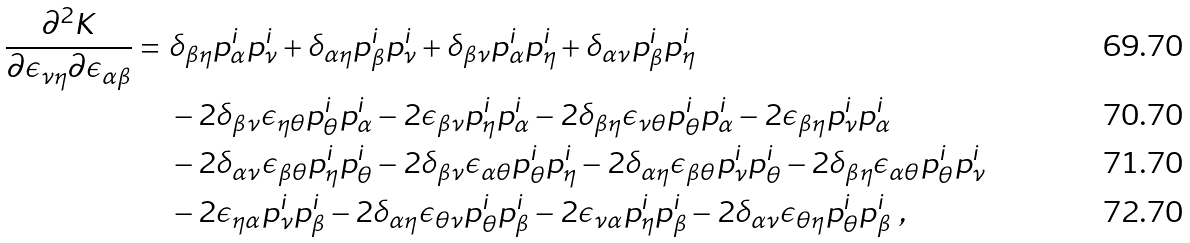<formula> <loc_0><loc_0><loc_500><loc_500>\frac { \partial ^ { 2 } K } { \partial \epsilon _ { \nu \eta } \partial \epsilon _ { \alpha \beta } } = \ & \delta _ { \beta \eta } p ^ { i } _ { \alpha } p ^ { i } _ { \nu } + \delta _ { \alpha \eta } p ^ { i } _ { \beta } p ^ { i } _ { \nu } + \delta _ { \beta \nu } p ^ { i } _ { \alpha } p ^ { i } _ { \eta } + \delta _ { \alpha \nu } p ^ { i } _ { \beta } p ^ { i } _ { \eta } \\ & - 2 \delta _ { \beta \nu } \epsilon _ { \eta \theta } p ^ { i } _ { \theta } p ^ { i } _ { \alpha } - 2 \epsilon _ { \beta \nu } p ^ { i } _ { \eta } p ^ { i } _ { \alpha } - 2 \delta _ { \beta \eta } \epsilon _ { \nu \theta } p ^ { i } _ { \theta } p ^ { i } _ { \alpha } - 2 \epsilon _ { \beta \eta } p ^ { i } _ { \nu } p ^ { i } _ { \alpha } \\ & - 2 \delta _ { \alpha \nu } \epsilon _ { \beta \theta } p ^ { i } _ { \eta } p ^ { i } _ { \theta } - 2 \delta _ { \beta \nu } \epsilon _ { \alpha \theta } p ^ { i } _ { \theta } p ^ { i } _ { \eta } - 2 \delta _ { \alpha \eta } \epsilon _ { \beta \theta } p ^ { i } _ { \nu } p ^ { i } _ { \theta } - 2 \delta _ { \beta \eta } \epsilon _ { \alpha \theta } p ^ { i } _ { \theta } p ^ { i } _ { \nu } \\ & - 2 \epsilon _ { \eta \alpha } p ^ { i } _ { \nu } p ^ { i } _ { \beta } - 2 \delta _ { \alpha \eta } \epsilon _ { \theta \nu } p ^ { i } _ { \theta } p ^ { i } _ { \beta } - 2 \epsilon _ { \nu \alpha } p ^ { i } _ { \eta } p ^ { i } _ { \beta } - 2 \delta _ { \alpha \nu } \epsilon _ { \theta \eta } p ^ { i } _ { \theta } p ^ { i } _ { \beta } \ ,</formula> 